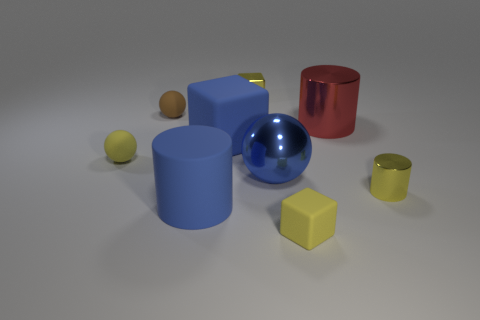Subtract all big blue matte blocks. How many blocks are left? 2 Add 1 large red metal objects. How many objects exist? 10 Subtract 1 balls. How many balls are left? 2 Add 4 blue things. How many blue things exist? 7 Subtract all yellow blocks. How many blocks are left? 1 Subtract 1 brown balls. How many objects are left? 8 Subtract all spheres. How many objects are left? 6 Subtract all cyan blocks. Subtract all red balls. How many blocks are left? 3 Subtract all yellow cubes. How many red cylinders are left? 1 Subtract all large things. Subtract all small metallic cubes. How many objects are left? 4 